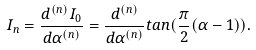<formula> <loc_0><loc_0><loc_500><loc_500>I _ { n } = \frac { d ^ { ( n ) } I _ { 0 } } { d \alpha ^ { ( n ) } } = \frac { d ^ { ( n ) } } { d \alpha ^ { ( n ) } } t a n ( \frac { \pi } { 2 } ( \alpha - 1 ) ) .</formula> 